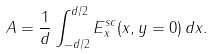Convert formula to latex. <formula><loc_0><loc_0><loc_500><loc_500>A = \frac { 1 } { d } \int _ { - d / 2 } ^ { d / 2 } E _ { x } ^ { s c } ( x , y = 0 ) \, d x .</formula> 